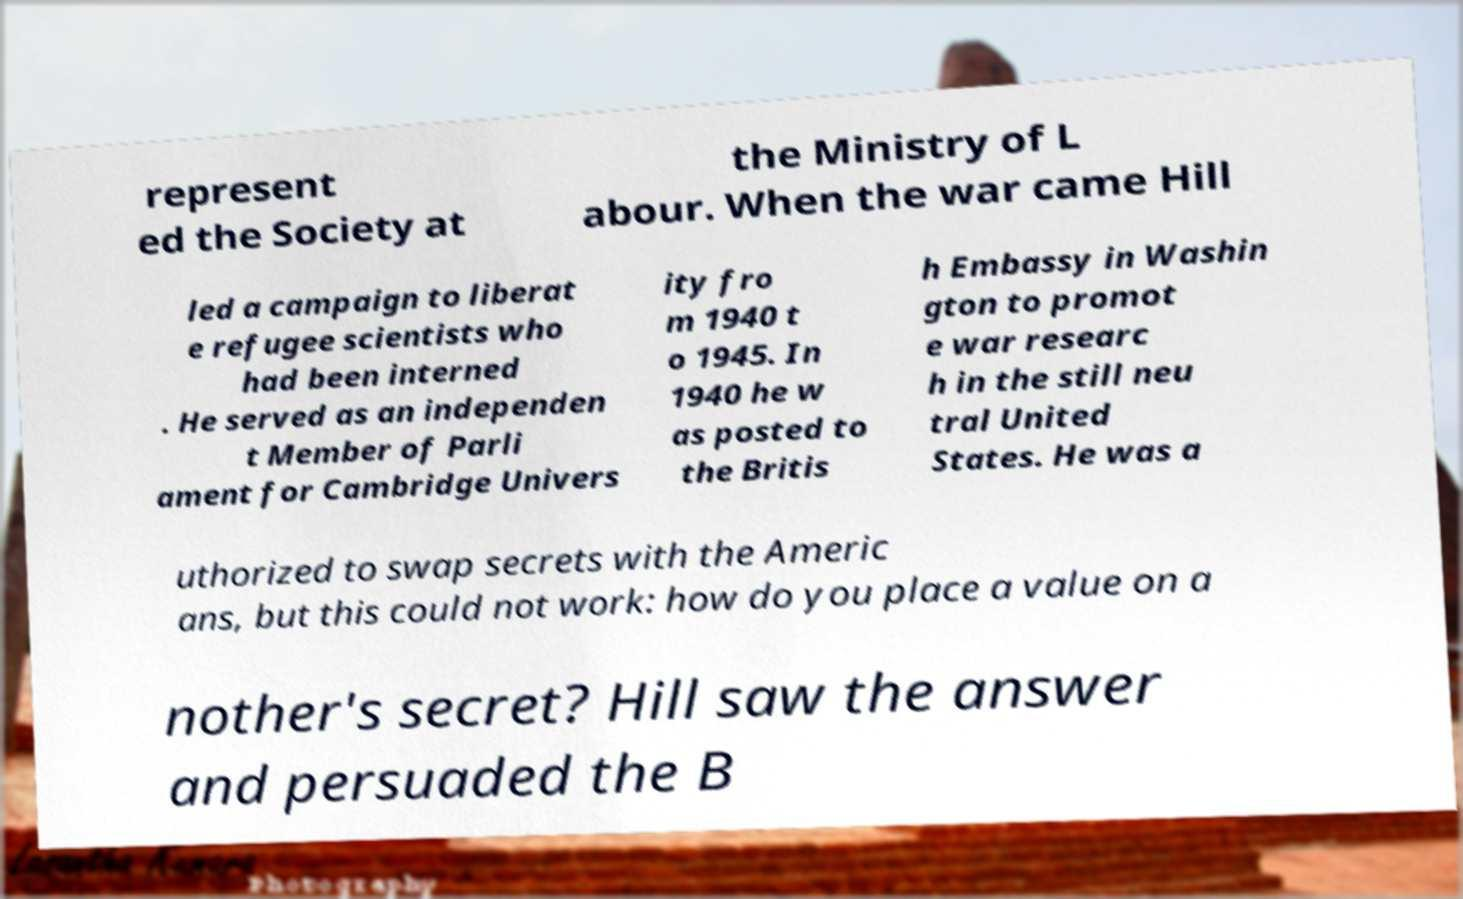For documentation purposes, I need the text within this image transcribed. Could you provide that? represent ed the Society at the Ministry of L abour. When the war came Hill led a campaign to liberat e refugee scientists who had been interned . He served as an independen t Member of Parli ament for Cambridge Univers ity fro m 1940 t o 1945. In 1940 he w as posted to the Britis h Embassy in Washin gton to promot e war researc h in the still neu tral United States. He was a uthorized to swap secrets with the Americ ans, but this could not work: how do you place a value on a nother's secret? Hill saw the answer and persuaded the B 